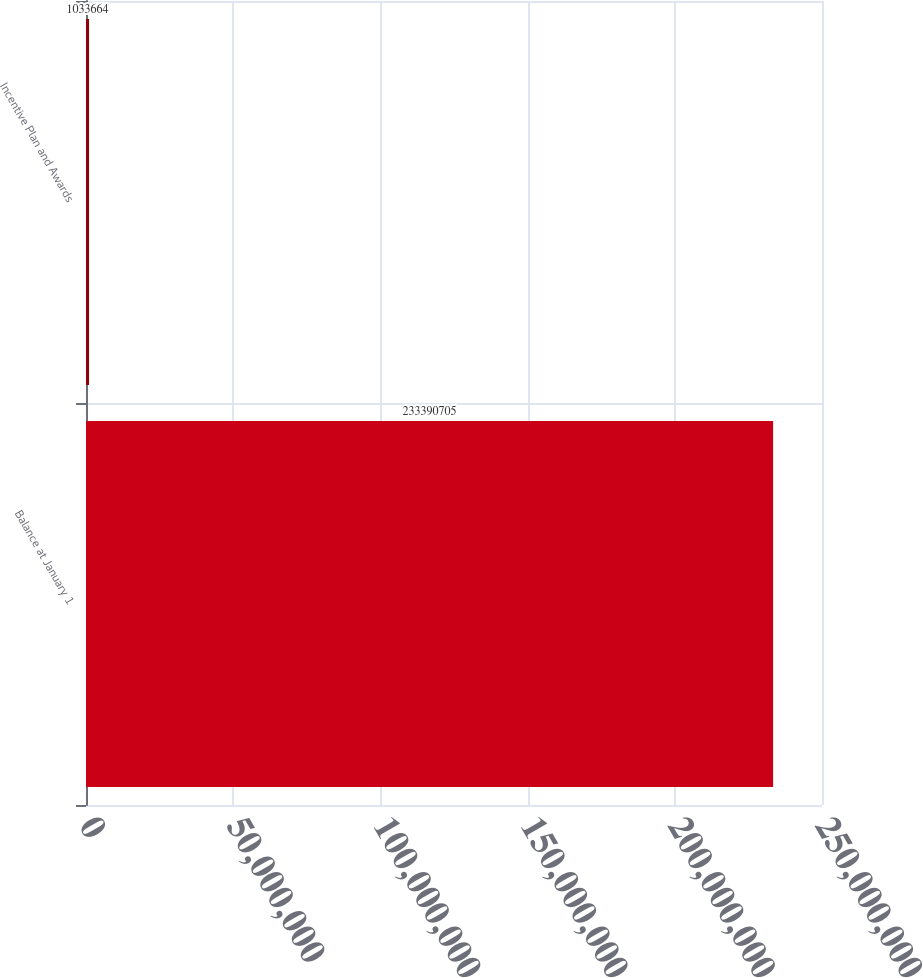Convert chart. <chart><loc_0><loc_0><loc_500><loc_500><bar_chart><fcel>Balance at January 1<fcel>Incentive Plan and Awards<nl><fcel>2.33391e+08<fcel>1.03366e+06<nl></chart> 